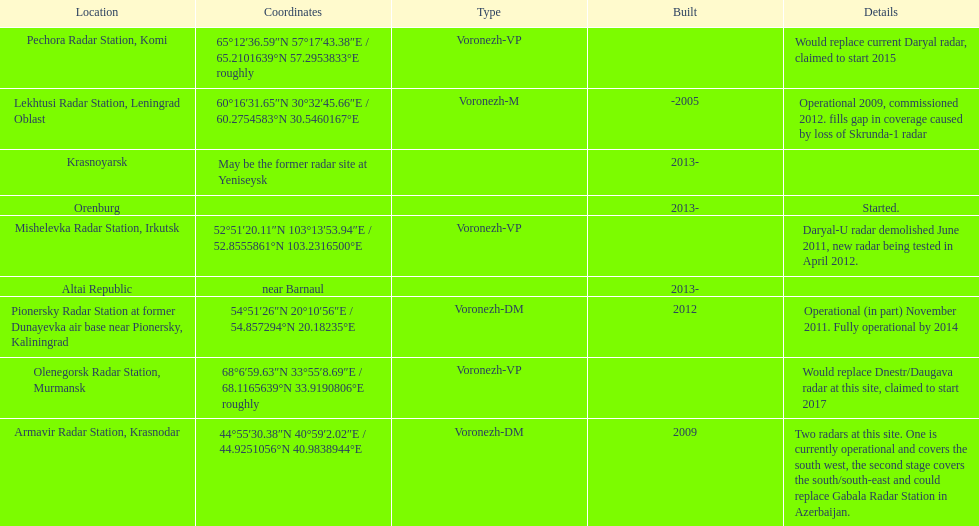How many voronezh radars were built before 2010? 2. 